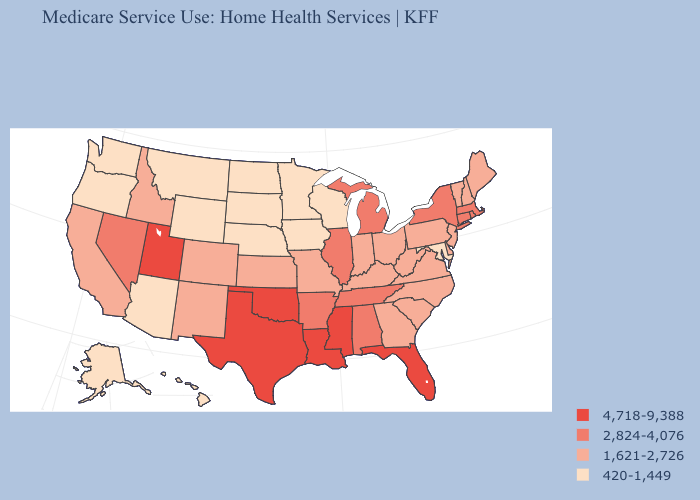Does Oregon have the lowest value in the USA?
Concise answer only. Yes. What is the highest value in the South ?
Short answer required. 4,718-9,388. Name the states that have a value in the range 2,824-4,076?
Be succinct. Alabama, Arkansas, Connecticut, Illinois, Massachusetts, Michigan, Nevada, New York, Rhode Island, Tennessee. What is the value of Texas?
Give a very brief answer. 4,718-9,388. Name the states that have a value in the range 4,718-9,388?
Write a very short answer. Florida, Louisiana, Mississippi, Oklahoma, Texas, Utah. What is the lowest value in states that border West Virginia?
Short answer required. 420-1,449. What is the value of New Hampshire?
Write a very short answer. 1,621-2,726. Does Tennessee have a lower value than Oklahoma?
Write a very short answer. Yes. Is the legend a continuous bar?
Write a very short answer. No. Does Arkansas have the lowest value in the South?
Short answer required. No. Does Utah have the highest value in the West?
Answer briefly. Yes. What is the value of Georgia?
Answer briefly. 1,621-2,726. What is the highest value in states that border Pennsylvania?
Give a very brief answer. 2,824-4,076. What is the value of Pennsylvania?
Answer briefly. 1,621-2,726. Name the states that have a value in the range 1,621-2,726?
Short answer required. California, Colorado, Delaware, Georgia, Idaho, Indiana, Kansas, Kentucky, Maine, Missouri, New Hampshire, New Jersey, New Mexico, North Carolina, Ohio, Pennsylvania, South Carolina, Vermont, Virginia, West Virginia. 